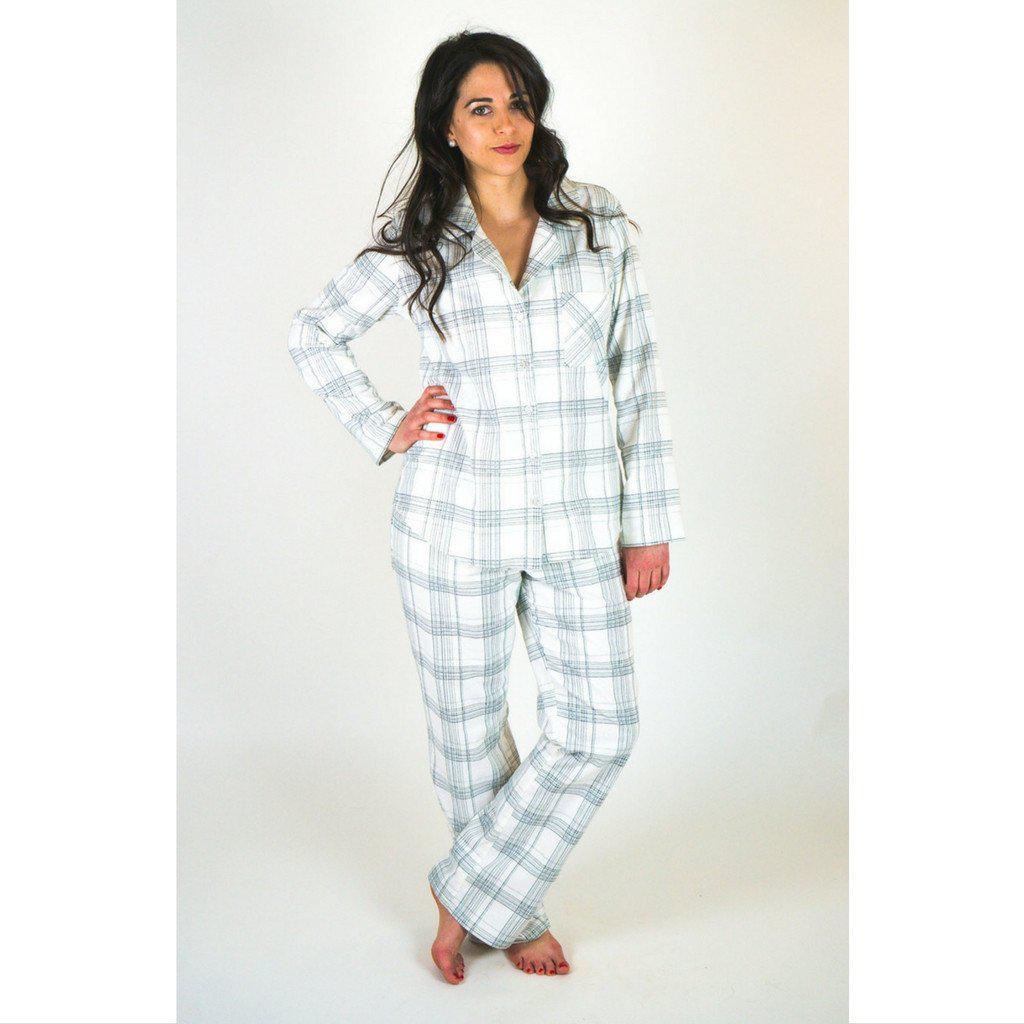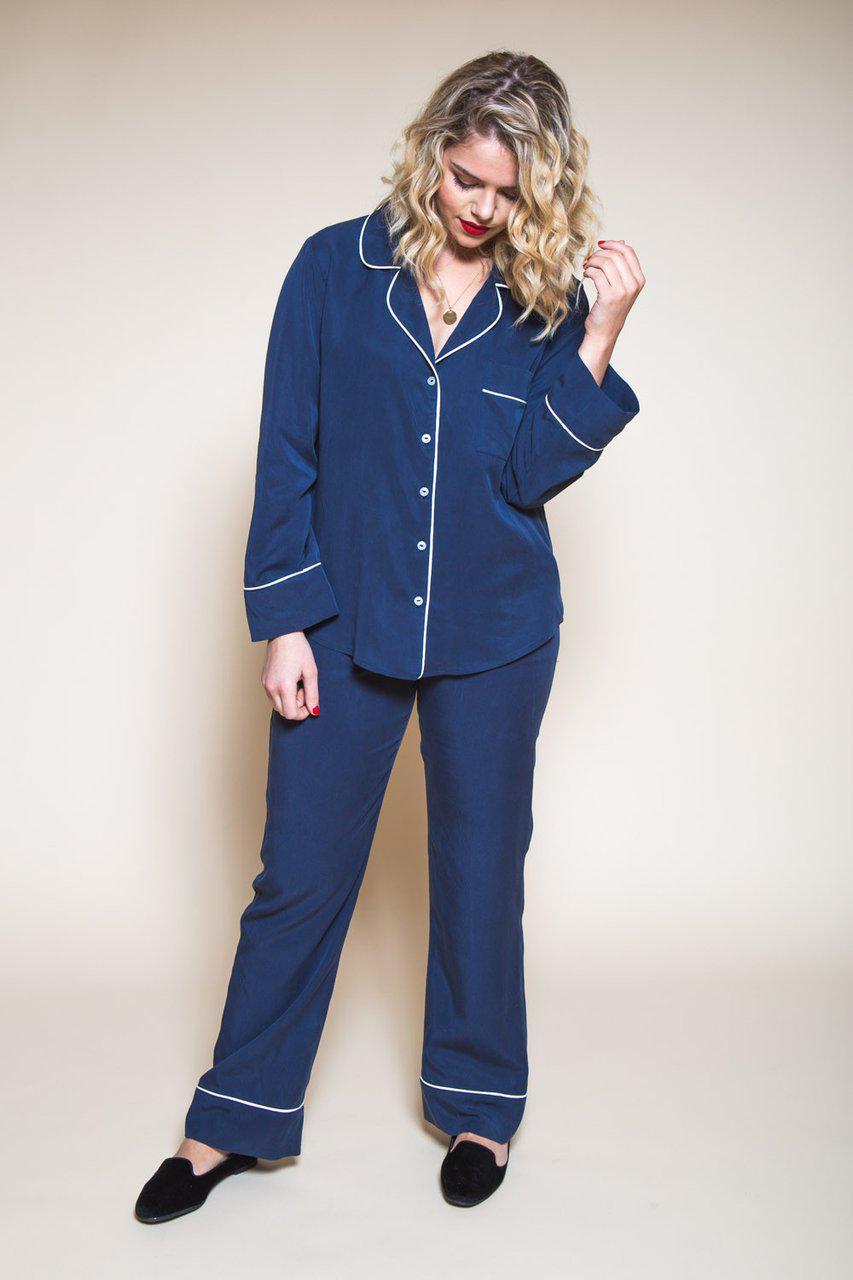The first image is the image on the left, the second image is the image on the right. Evaluate the accuracy of this statement regarding the images: "A woman is wearing pajamas with small flowers on a dark purple background.". Is it true? Answer yes or no. No. The first image is the image on the left, the second image is the image on the right. Assess this claim about the two images: "The woman in one of the image is wearing a pair of glasses.". Correct or not? Answer yes or no. No. 